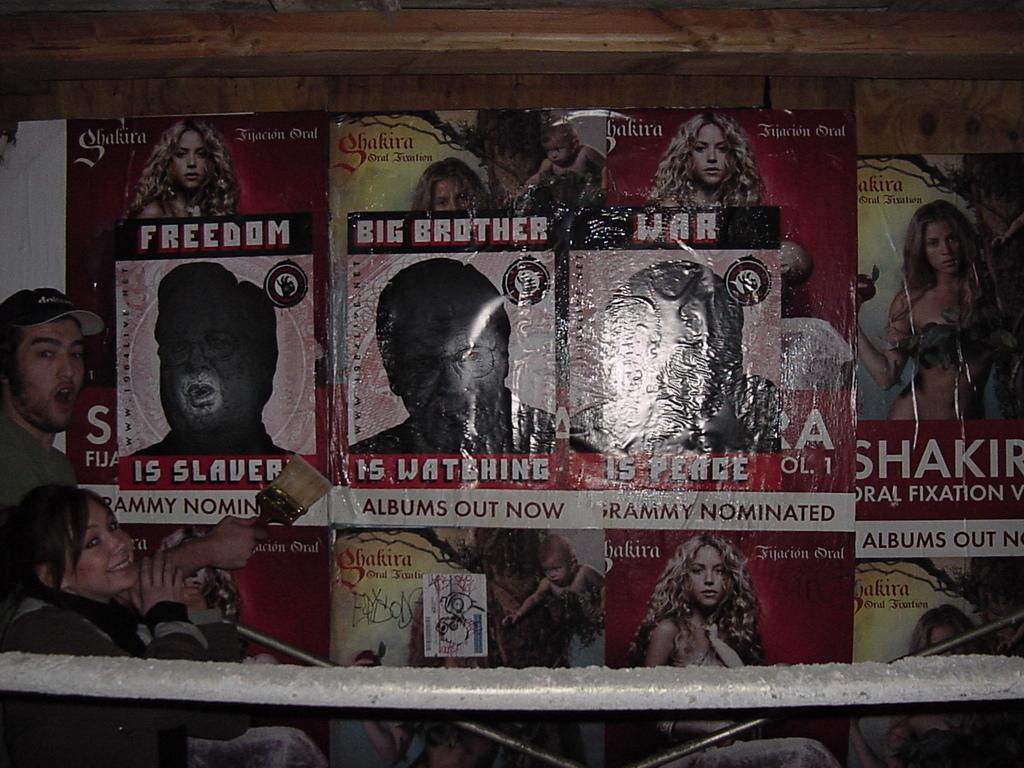Could you give a brief overview of what you see in this image? In this picture we can see posters in the background, on the left side there are two persons, a man on the left side is holding a brush, we can see pictures of persons on these posters. 